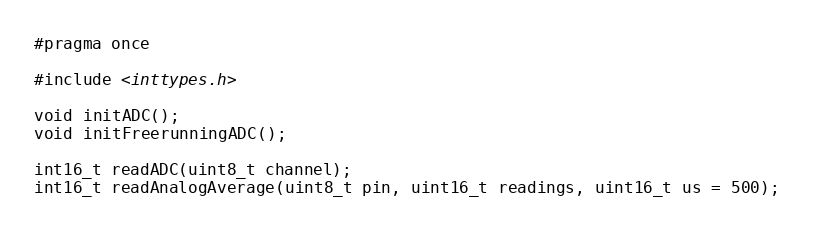<code> <loc_0><loc_0><loc_500><loc_500><_C++_>#pragma once

#include <inttypes.h>

void initADC();
void initFreerunningADC();

int16_t readADC(uint8_t channel);
int16_t readAnalogAverage(uint8_t pin, uint16_t readings, uint16_t us = 500);</code> 